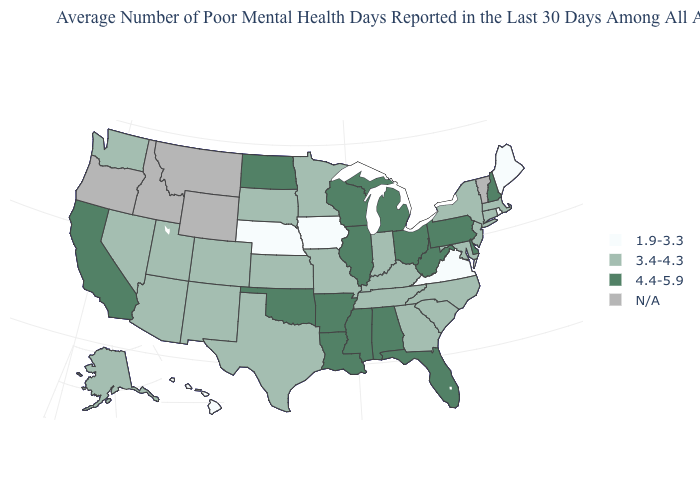How many symbols are there in the legend?
Answer briefly. 4. What is the value of Idaho?
Write a very short answer. N/A. What is the value of Mississippi?
Give a very brief answer. 4.4-5.9. What is the lowest value in the USA?
Write a very short answer. 1.9-3.3. Name the states that have a value in the range 3.4-4.3?
Give a very brief answer. Alaska, Arizona, Colorado, Connecticut, Georgia, Indiana, Kansas, Kentucky, Maryland, Massachusetts, Minnesota, Missouri, Nevada, New Jersey, New Mexico, New York, North Carolina, South Carolina, South Dakota, Tennessee, Texas, Utah, Washington. Name the states that have a value in the range 3.4-4.3?
Be succinct. Alaska, Arizona, Colorado, Connecticut, Georgia, Indiana, Kansas, Kentucky, Maryland, Massachusetts, Minnesota, Missouri, Nevada, New Jersey, New Mexico, New York, North Carolina, South Carolina, South Dakota, Tennessee, Texas, Utah, Washington. What is the value of Massachusetts?
Keep it brief. 3.4-4.3. Name the states that have a value in the range N/A?
Keep it brief. Idaho, Montana, Oregon, Vermont, Wyoming. Does Virginia have the lowest value in the USA?
Quick response, please. Yes. Among the states that border Mississippi , does Tennessee have the lowest value?
Answer briefly. Yes. Which states have the lowest value in the USA?
Give a very brief answer. Hawaii, Iowa, Maine, Nebraska, Rhode Island, Virginia. What is the highest value in the Northeast ?
Be succinct. 4.4-5.9. Does the first symbol in the legend represent the smallest category?
Answer briefly. Yes. Among the states that border Arkansas , which have the highest value?
Write a very short answer. Louisiana, Mississippi, Oklahoma. 